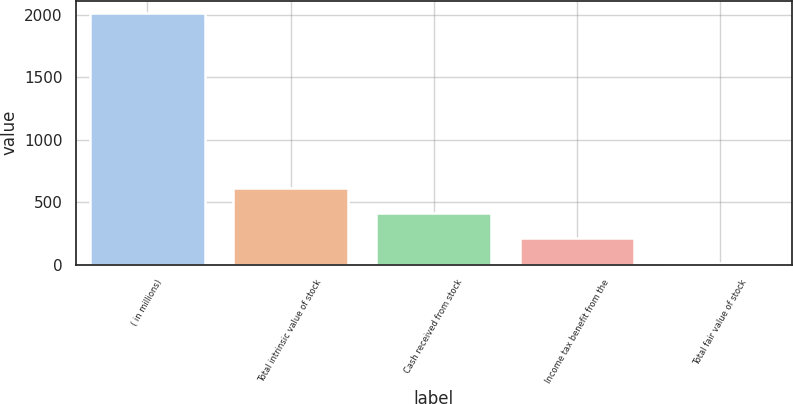<chart> <loc_0><loc_0><loc_500><loc_500><bar_chart><fcel>( in millions)<fcel>Total intrinsic value of stock<fcel>Cash received from stock<fcel>Income tax benefit from the<fcel>Total fair value of stock<nl><fcel>2014<fcel>611.2<fcel>410.8<fcel>210.4<fcel>10<nl></chart> 